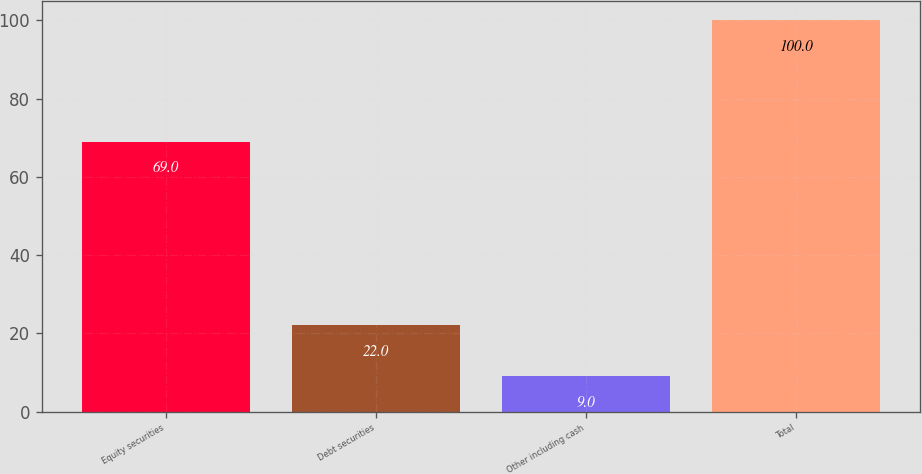Convert chart. <chart><loc_0><loc_0><loc_500><loc_500><bar_chart><fcel>Equity securities<fcel>Debt securities<fcel>Other including cash<fcel>Total<nl><fcel>69<fcel>22<fcel>9<fcel>100<nl></chart> 